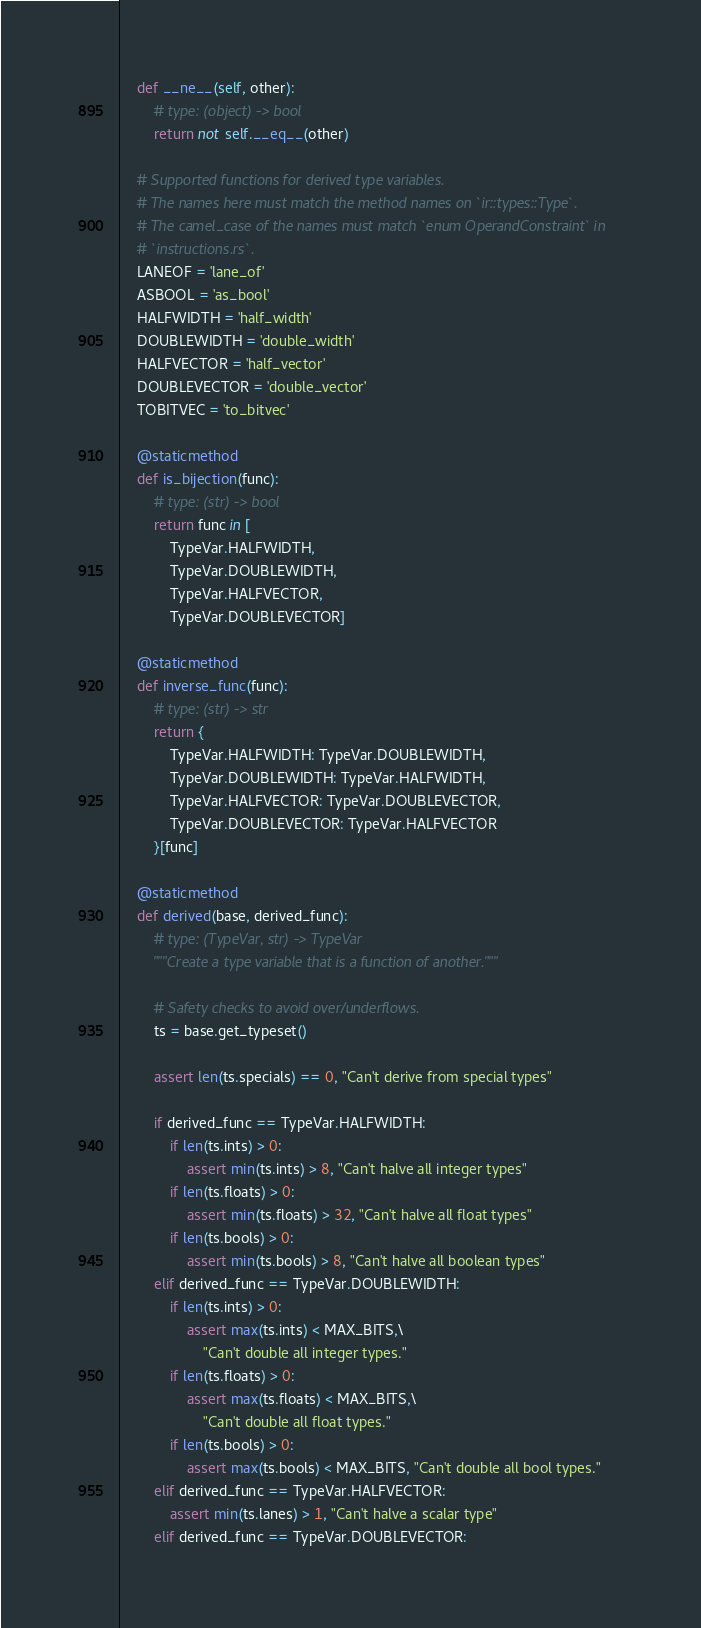Convert code to text. <code><loc_0><loc_0><loc_500><loc_500><_Python_>    def __ne__(self, other):
        # type: (object) -> bool
        return not self.__eq__(other)

    # Supported functions for derived type variables.
    # The names here must match the method names on `ir::types::Type`.
    # The camel_case of the names must match `enum OperandConstraint` in
    # `instructions.rs`.
    LANEOF = 'lane_of'
    ASBOOL = 'as_bool'
    HALFWIDTH = 'half_width'
    DOUBLEWIDTH = 'double_width'
    HALFVECTOR = 'half_vector'
    DOUBLEVECTOR = 'double_vector'
    TOBITVEC = 'to_bitvec'

    @staticmethod
    def is_bijection(func):
        # type: (str) -> bool
        return func in [
            TypeVar.HALFWIDTH,
            TypeVar.DOUBLEWIDTH,
            TypeVar.HALFVECTOR,
            TypeVar.DOUBLEVECTOR]

    @staticmethod
    def inverse_func(func):
        # type: (str) -> str
        return {
            TypeVar.HALFWIDTH: TypeVar.DOUBLEWIDTH,
            TypeVar.DOUBLEWIDTH: TypeVar.HALFWIDTH,
            TypeVar.HALFVECTOR: TypeVar.DOUBLEVECTOR,
            TypeVar.DOUBLEVECTOR: TypeVar.HALFVECTOR
        }[func]

    @staticmethod
    def derived(base, derived_func):
        # type: (TypeVar, str) -> TypeVar
        """Create a type variable that is a function of another."""

        # Safety checks to avoid over/underflows.
        ts = base.get_typeset()

        assert len(ts.specials) == 0, "Can't derive from special types"

        if derived_func == TypeVar.HALFWIDTH:
            if len(ts.ints) > 0:
                assert min(ts.ints) > 8, "Can't halve all integer types"
            if len(ts.floats) > 0:
                assert min(ts.floats) > 32, "Can't halve all float types"
            if len(ts.bools) > 0:
                assert min(ts.bools) > 8, "Can't halve all boolean types"
        elif derived_func == TypeVar.DOUBLEWIDTH:
            if len(ts.ints) > 0:
                assert max(ts.ints) < MAX_BITS,\
                    "Can't double all integer types."
            if len(ts.floats) > 0:
                assert max(ts.floats) < MAX_BITS,\
                    "Can't double all float types."
            if len(ts.bools) > 0:
                assert max(ts.bools) < MAX_BITS, "Can't double all bool types."
        elif derived_func == TypeVar.HALFVECTOR:
            assert min(ts.lanes) > 1, "Can't halve a scalar type"
        elif derived_func == TypeVar.DOUBLEVECTOR:</code> 